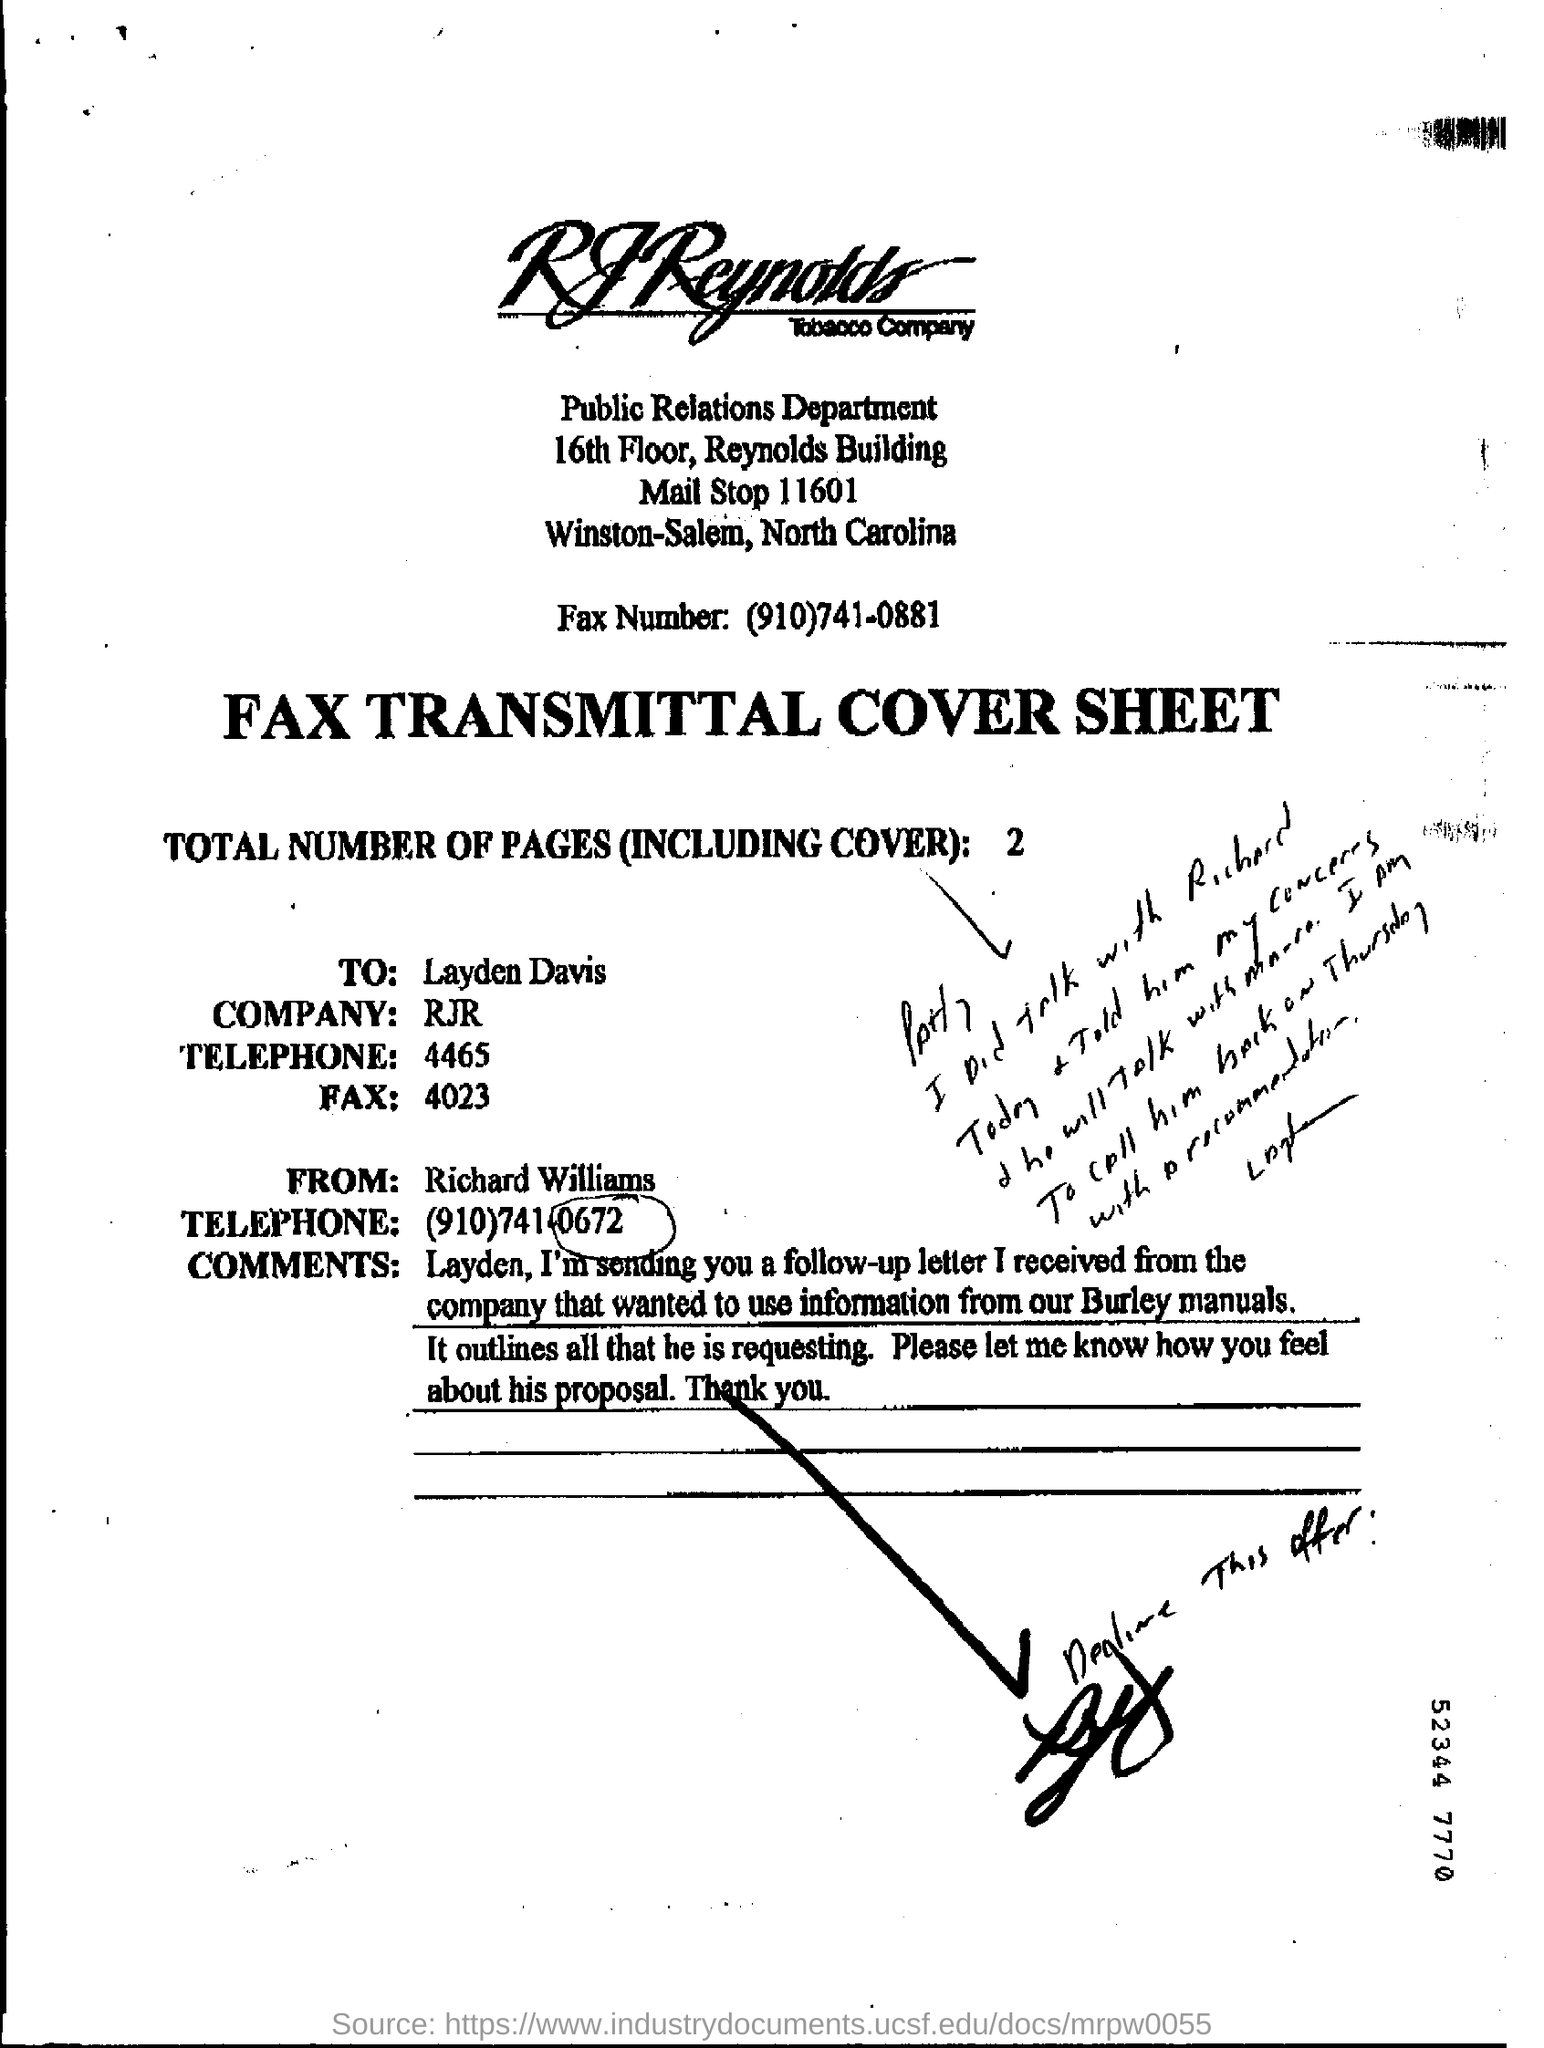What kind of document is this?
Offer a terse response. FAX TRANSMITTAL COVER SHEET. Who is the sender of the FAX?
Offer a terse response. Richard Williams. To whom, the Fax is being sent?
Offer a terse response. Layden Davis. What is the Telephone no of Richard Williams?
Your answer should be compact. (910)741-0672. 